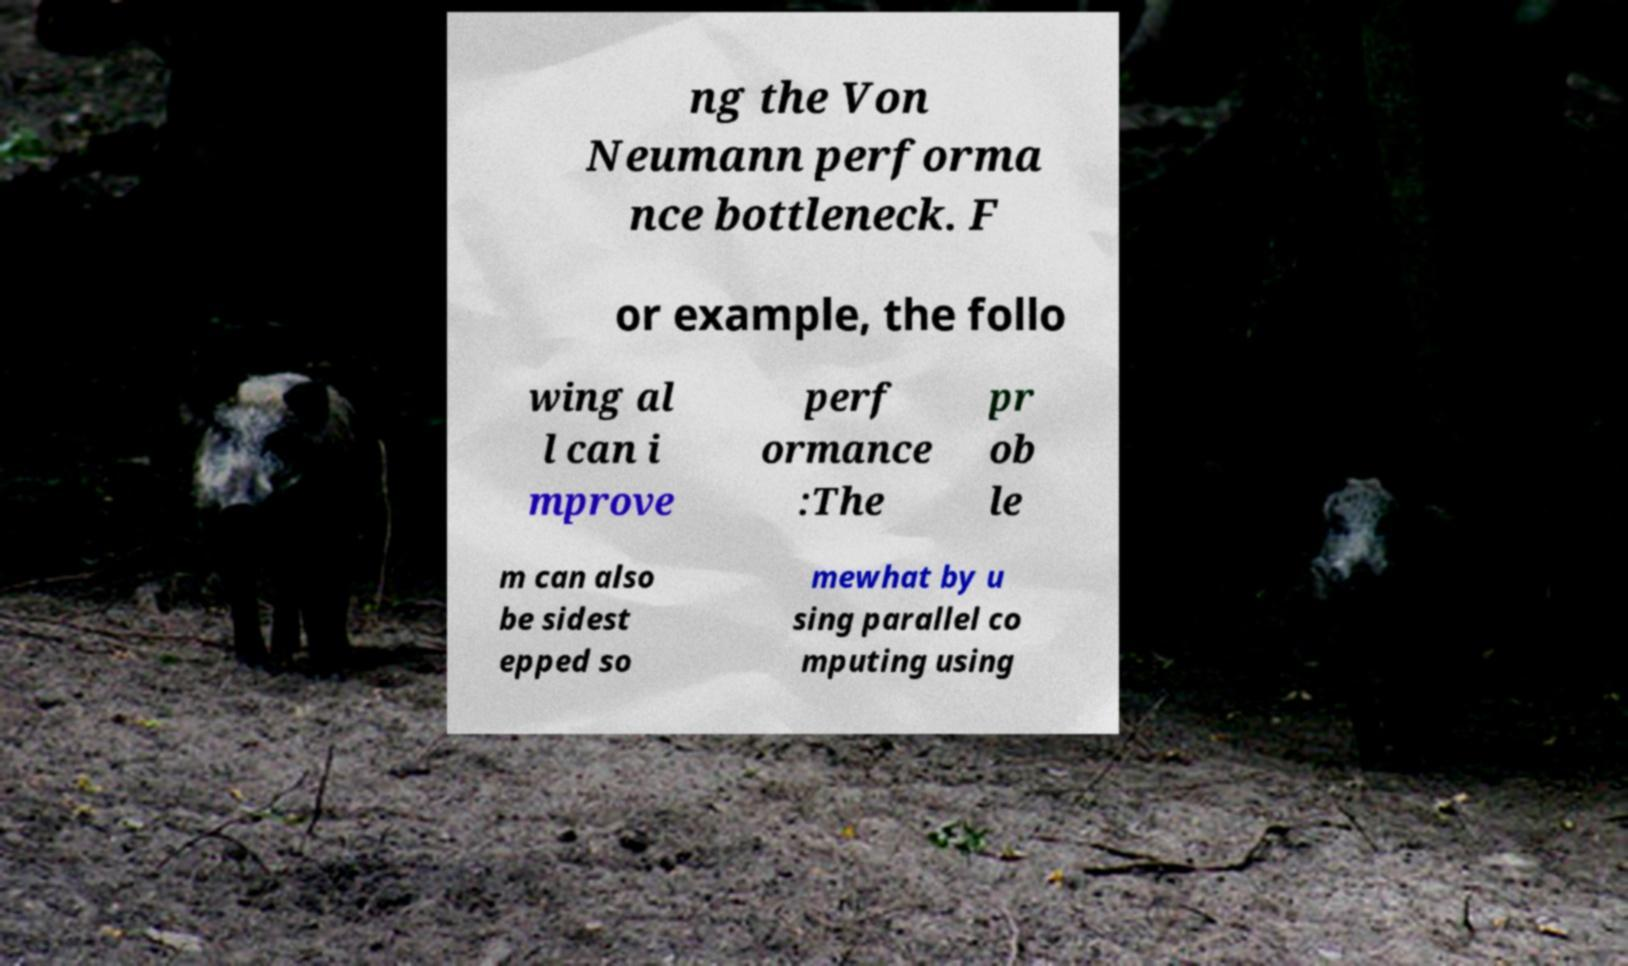Can you read and provide the text displayed in the image?This photo seems to have some interesting text. Can you extract and type it out for me? ng the Von Neumann performa nce bottleneck. F or example, the follo wing al l can i mprove perf ormance :The pr ob le m can also be sidest epped so mewhat by u sing parallel co mputing using 